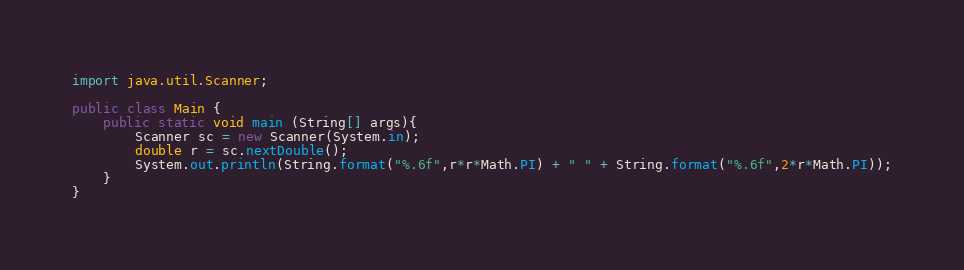<code> <loc_0><loc_0><loc_500><loc_500><_Java_>import java.util.Scanner;

public class Main {
    public static void main (String[] args){
        Scanner sc = new Scanner(System.in);
        double r = sc.nextDouble();
        System.out.println(String.format("%.6f",r*r*Math.PI) + " " + String.format("%.6f",2*r*Math.PI));
    }
}
</code> 